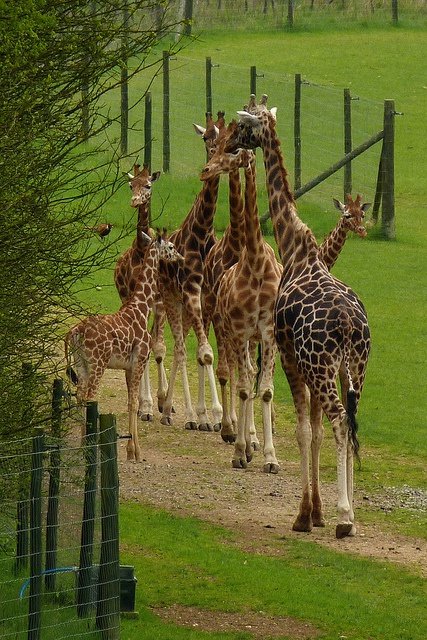Describe the objects in this image and their specific colors. I can see giraffe in darkgreen, black, olive, maroon, and tan tones, giraffe in darkgreen, olive, maroon, tan, and gray tones, giraffe in darkgreen, olive, maroon, gray, and tan tones, giraffe in darkgreen, black, maroon, olive, and tan tones, and giraffe in darkgreen, black, maroon, olive, and gray tones in this image. 